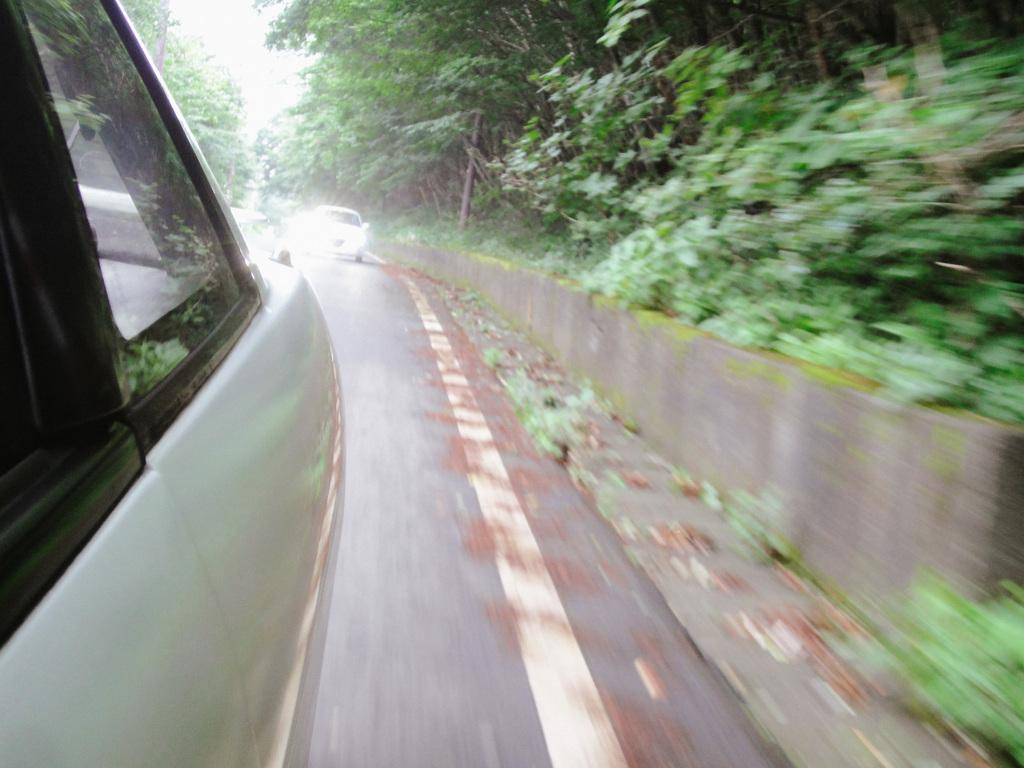What is present on the road in the image? There are vehicles on the road in the image. What type of vegetation can be seen in the image? There is tall grass, plants, and trees in the image. What part of the natural environment is visible in the image? The sky is visible in the image. What is the size of the mouth on the tree in the image? There is no mouth present on any tree in the image. How many spots can be seen on the vehicles in the image? There is no mention of spots on the vehicles in the image. 